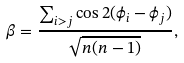<formula> <loc_0><loc_0><loc_500><loc_500>\beta = \frac { \sum _ { i > j } \cos 2 ( \phi _ { i } - \phi _ { j } ) } { \sqrt { n ( n - 1 ) } } ,</formula> 